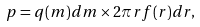Convert formula to latex. <formula><loc_0><loc_0><loc_500><loc_500>p = q ( m ) d m \times 2 \pi r f ( r ) d r ,</formula> 